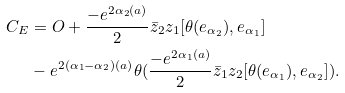<formula> <loc_0><loc_0><loc_500><loc_500>C _ { E } & = O + \frac { - e ^ { 2 \alpha _ { 2 } ( a ) } } { 2 } \bar { z } _ { 2 } z _ { 1 } [ \theta ( e _ { \alpha _ { 2 } } ) , e _ { \alpha _ { 1 } } ] \\ & - e ^ { 2 ( \alpha _ { 1 } - \alpha _ { 2 } ) ( a ) } \theta ( \frac { - e ^ { 2 \alpha _ { 1 } ( a ) } } { 2 } \bar { z } _ { 1 } z _ { 2 } [ \theta ( e _ { \alpha _ { 1 } } ) , e _ { \alpha _ { 2 } } ] ) .</formula> 